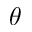<formula> <loc_0><loc_0><loc_500><loc_500>\theta</formula> 